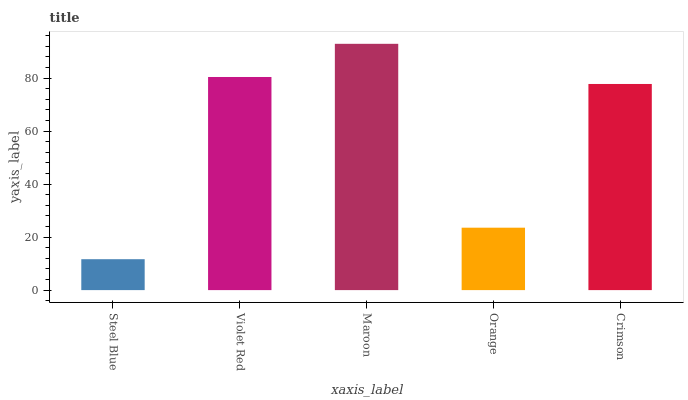Is Steel Blue the minimum?
Answer yes or no. Yes. Is Maroon the maximum?
Answer yes or no. Yes. Is Violet Red the minimum?
Answer yes or no. No. Is Violet Red the maximum?
Answer yes or no. No. Is Violet Red greater than Steel Blue?
Answer yes or no. Yes. Is Steel Blue less than Violet Red?
Answer yes or no. Yes. Is Steel Blue greater than Violet Red?
Answer yes or no. No. Is Violet Red less than Steel Blue?
Answer yes or no. No. Is Crimson the high median?
Answer yes or no. Yes. Is Crimson the low median?
Answer yes or no. Yes. Is Orange the high median?
Answer yes or no. No. Is Maroon the low median?
Answer yes or no. No. 